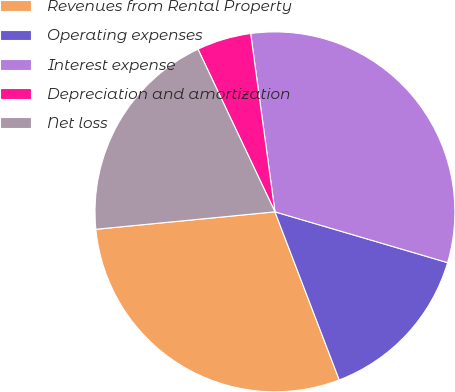Convert chart. <chart><loc_0><loc_0><loc_500><loc_500><pie_chart><fcel>Revenues from Rental Property<fcel>Operating expenses<fcel>Interest expense<fcel>Depreciation and amortization<fcel>Net loss<nl><fcel>29.27%<fcel>14.63%<fcel>31.71%<fcel>4.88%<fcel>19.51%<nl></chart> 